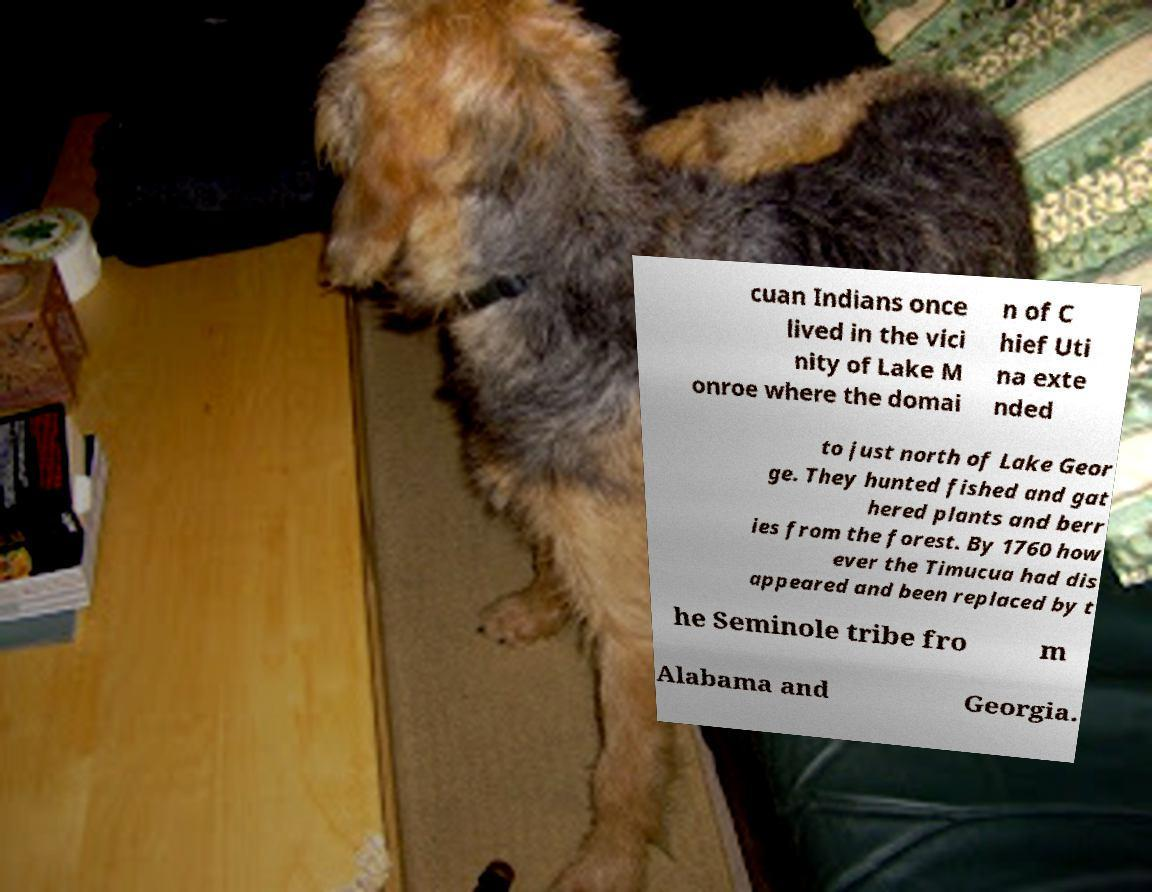Please read and relay the text visible in this image. What does it say? cuan Indians once lived in the vici nity of Lake M onroe where the domai n of C hief Uti na exte nded to just north of Lake Geor ge. They hunted fished and gat hered plants and berr ies from the forest. By 1760 how ever the Timucua had dis appeared and been replaced by t he Seminole tribe fro m Alabama and Georgia. 